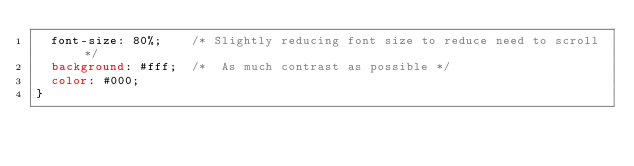<code> <loc_0><loc_0><loc_500><loc_500><_CSS_>  font-size: 80%;    /* Slightly reducing font size to reduce need to scroll */ 
  background: #fff;  /*  As much contrast as possible */
  color: #000;
}
</code> 